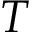Convert formula to latex. <formula><loc_0><loc_0><loc_500><loc_500>T</formula> 